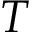Convert formula to latex. <formula><loc_0><loc_0><loc_500><loc_500>T</formula> 